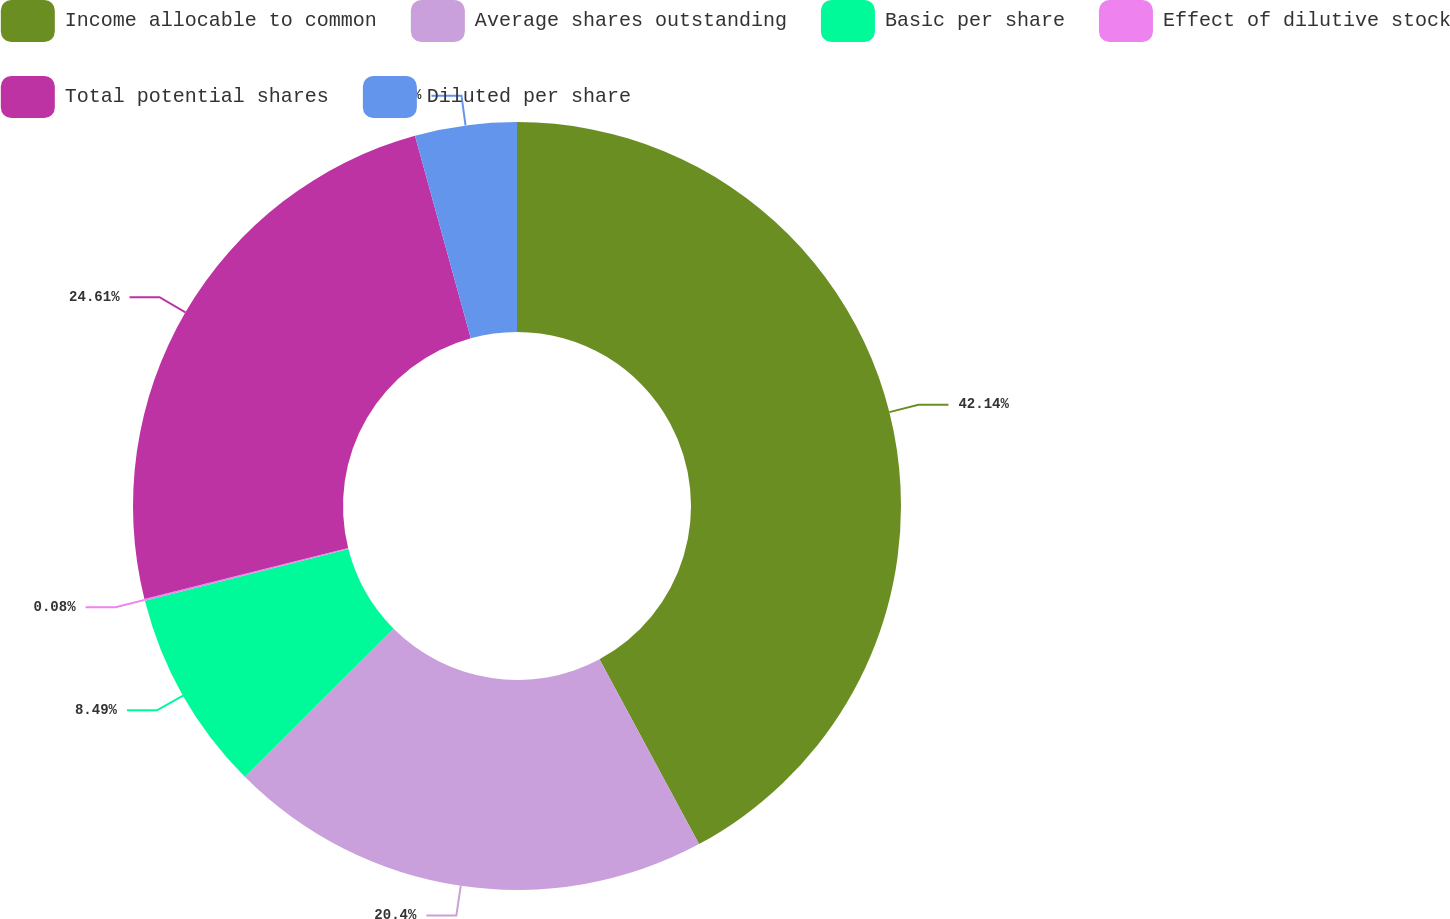Convert chart. <chart><loc_0><loc_0><loc_500><loc_500><pie_chart><fcel>Income allocable to common<fcel>Average shares outstanding<fcel>Basic per share<fcel>Effect of dilutive stock<fcel>Total potential shares<fcel>Diluted per share<nl><fcel>42.14%<fcel>20.4%<fcel>8.49%<fcel>0.08%<fcel>24.61%<fcel>4.28%<nl></chart> 